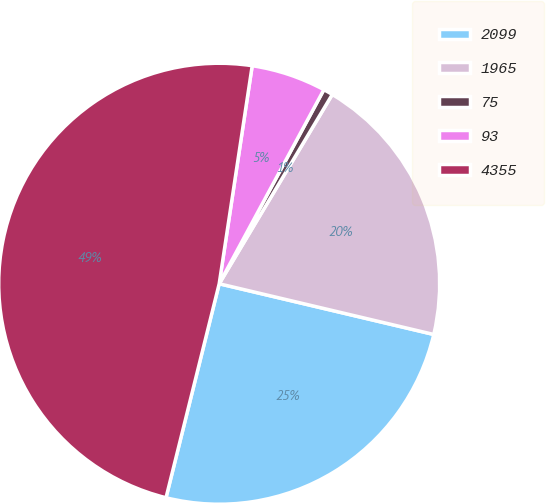Convert chart. <chart><loc_0><loc_0><loc_500><loc_500><pie_chart><fcel>2099<fcel>1965<fcel>75<fcel>93<fcel>4355<nl><fcel>25.18%<fcel>20.12%<fcel>0.7%<fcel>5.48%<fcel>48.51%<nl></chart> 